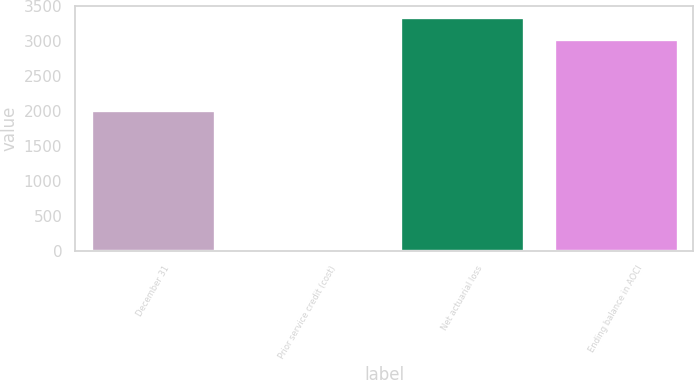<chart> <loc_0><loc_0><loc_500><loc_500><bar_chart><fcel>December 31<fcel>Prior service credit (cost)<fcel>Net actuarial loss<fcel>Ending balance in AOCI<nl><fcel>2012<fcel>16<fcel>3335.2<fcel>3032<nl></chart> 